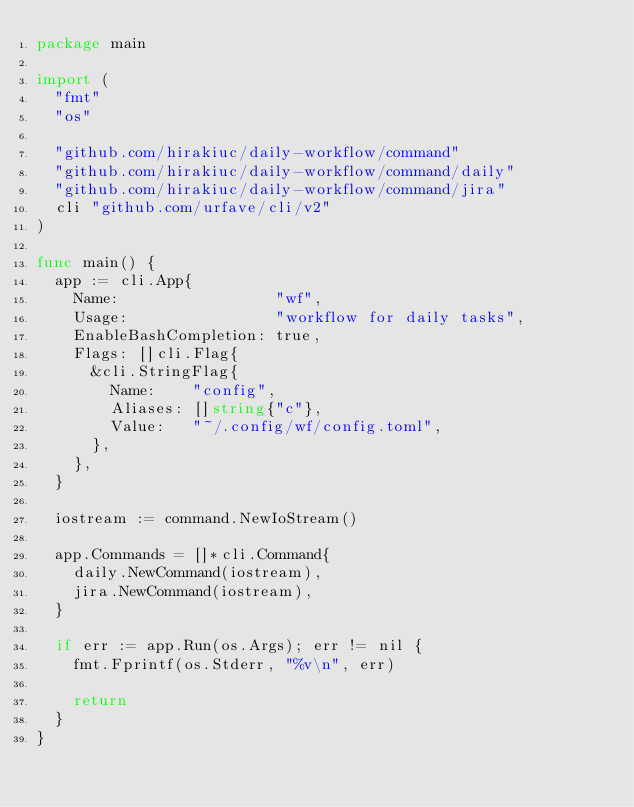<code> <loc_0><loc_0><loc_500><loc_500><_Go_>package main

import (
	"fmt"
	"os"

	"github.com/hirakiuc/daily-workflow/command"
	"github.com/hirakiuc/daily-workflow/command/daily"
	"github.com/hirakiuc/daily-workflow/command/jira"
	cli "github.com/urfave/cli/v2"
)

func main() {
	app := cli.App{
		Name:                 "wf",
		Usage:                "workflow for daily tasks",
		EnableBashCompletion: true,
		Flags: []cli.Flag{
			&cli.StringFlag{
				Name:    "config",
				Aliases: []string{"c"},
				Value:   "~/.config/wf/config.toml",
			},
		},
	}

	iostream := command.NewIoStream()

	app.Commands = []*cli.Command{
		daily.NewCommand(iostream),
		jira.NewCommand(iostream),
	}

	if err := app.Run(os.Args); err != nil {
		fmt.Fprintf(os.Stderr, "%v\n", err)

		return
	}
}
</code> 